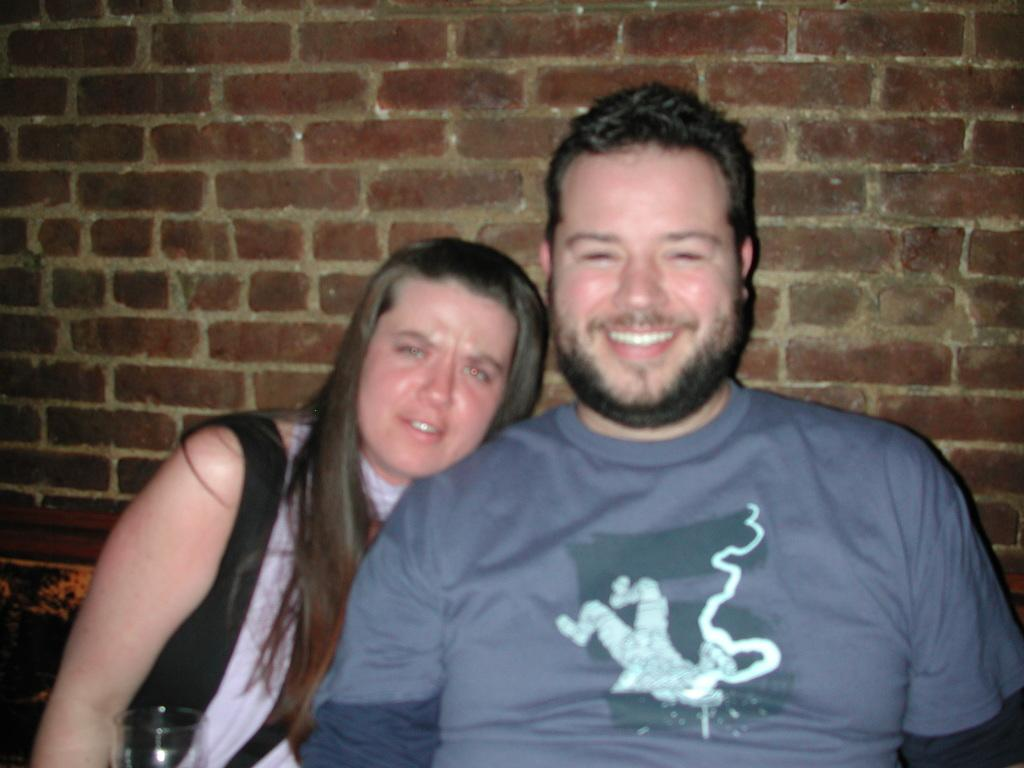How many people are in the image? There are two people in the image, a woman and a man. What are the people in the image doing? The woman and the man are sitting and smiling, posing for the picture. What can be seen in the bottom left-hand corner of the image? There is a glass in the bottom left-hand corner of the image. What is behind the people in the image? There is a wall behind the people in the image. What degree does the cook have in the image? There is no cook present in the image, and therefore no degree can be attributed to a cook. 